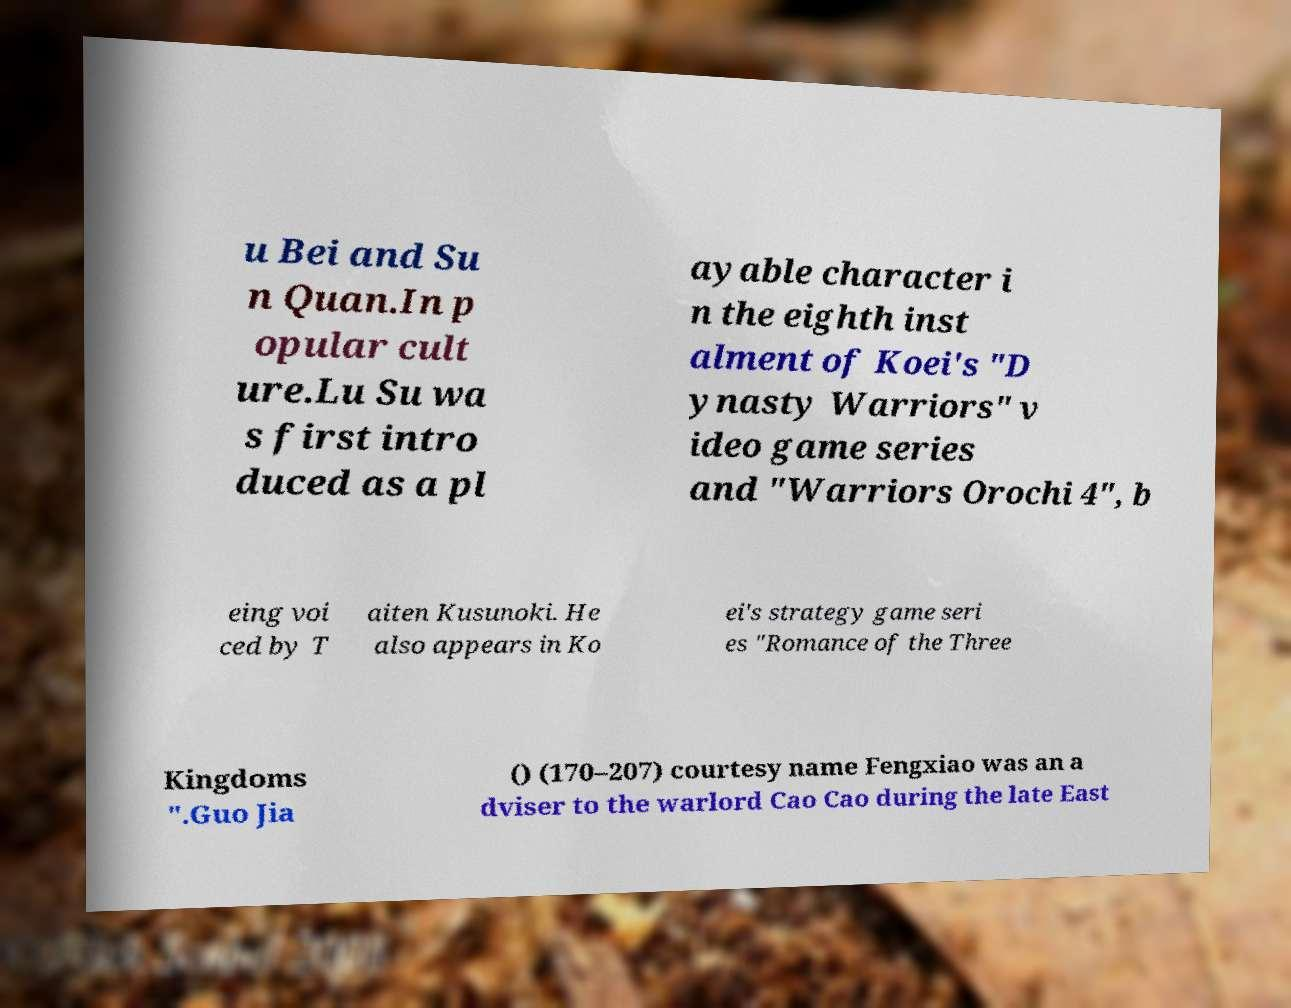Please identify and transcribe the text found in this image. u Bei and Su n Quan.In p opular cult ure.Lu Su wa s first intro duced as a pl ayable character i n the eighth inst alment of Koei's "D ynasty Warriors" v ideo game series and "Warriors Orochi 4", b eing voi ced by T aiten Kusunoki. He also appears in Ko ei's strategy game seri es "Romance of the Three Kingdoms ".Guo Jia () (170–207) courtesy name Fengxiao was an a dviser to the warlord Cao Cao during the late East 